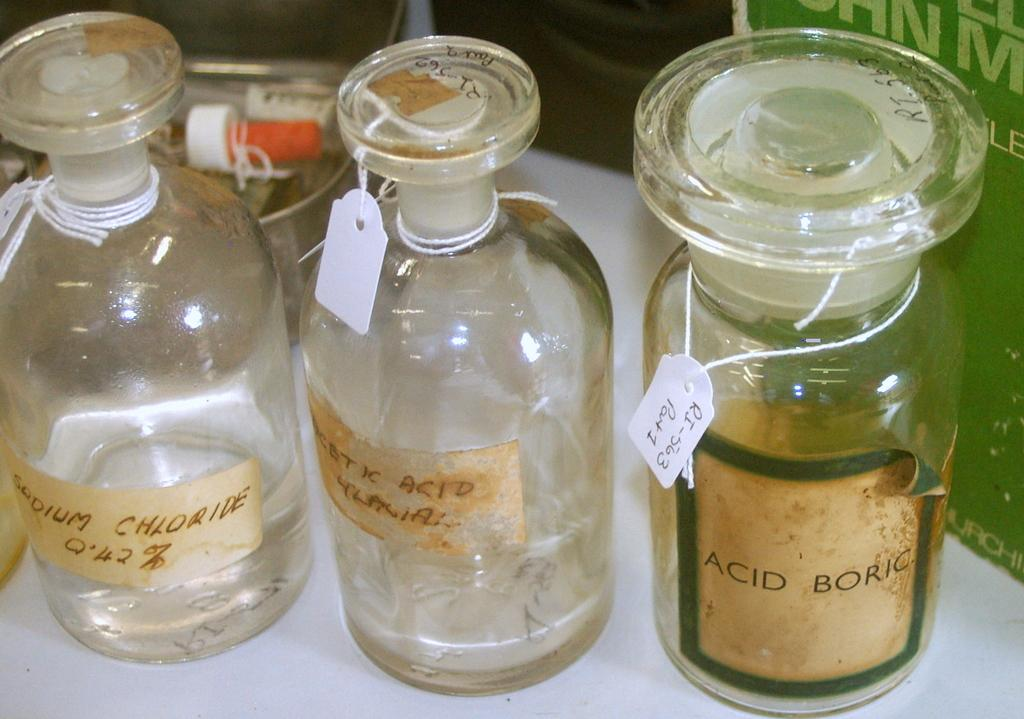<image>
Relay a brief, clear account of the picture shown. three glass jars with one of them labeled as 'acid boric' 